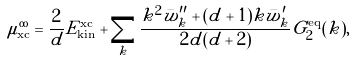<formula> <loc_0><loc_0><loc_500><loc_500>\mu _ { \text {xc} } ^ { \infty } = \frac { 2 } { d } E _ { \text {kin} } ^ { { \text {xc} } } + \sum _ { k } \frac { k ^ { 2 } \bar { w } ^ { \prime \prime } _ { k } + ( d + 1 ) k \bar { w } ^ { \prime } _ { k } } { 2 d ( d + 2 ) } G _ { 2 } ^ { \text {eq} } ( k ) ,</formula> 